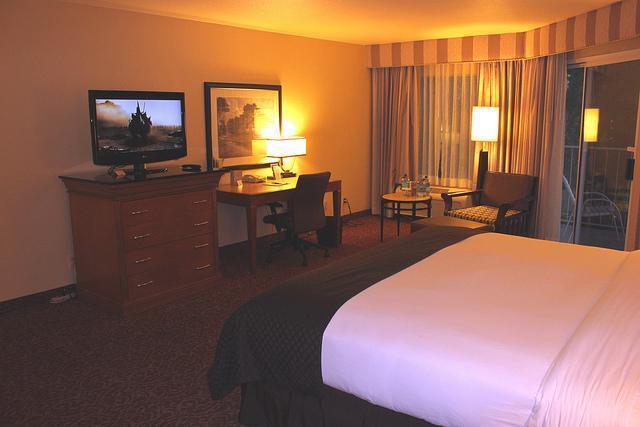What are in the bottles on the right?
Choose the right answer and clarify with the format: 'Answer: answer
Rationale: rationale.'
Options: Wine, water, gin, beer. Answer: water.
Rationale: The bottles have water. 